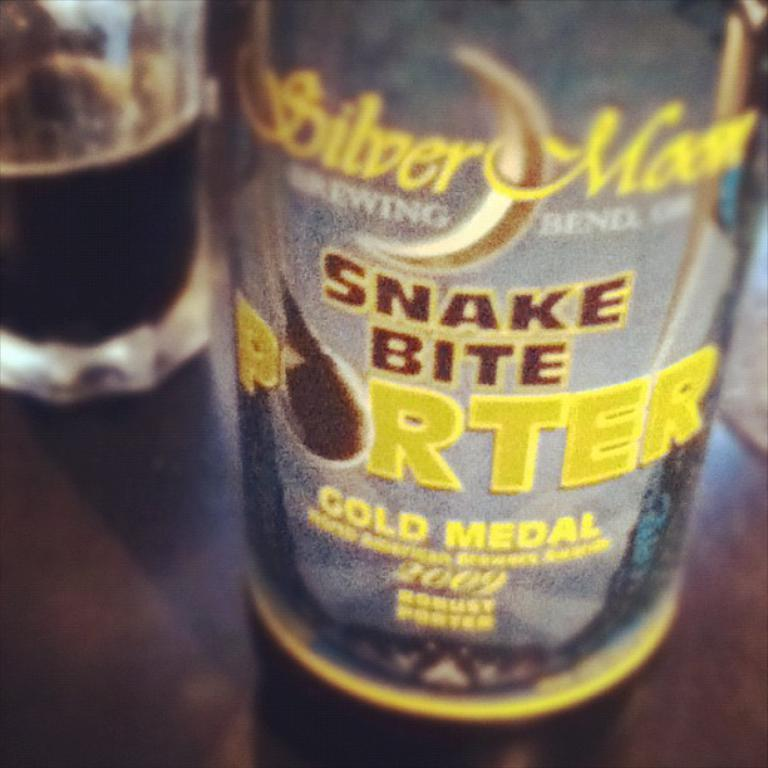What type of container is visible in the image? There is a bottle in the image. What other container can be seen in the image? There is a glass in the image. Where are the containers located in the image? The containers are located on a table at the bottom of the image. What type of heart can be seen beating in the image? There is no heart visible in the image; it only contains a bottle and a glass on a table. 